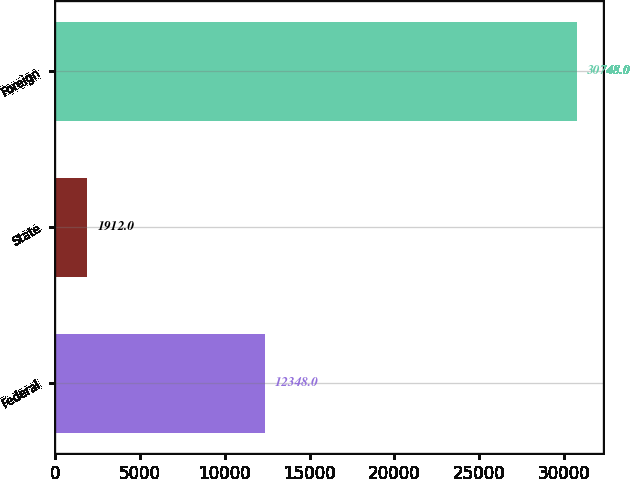Convert chart to OTSL. <chart><loc_0><loc_0><loc_500><loc_500><bar_chart><fcel>Federal<fcel>State<fcel>Foreign<nl><fcel>12348<fcel>1912<fcel>30748<nl></chart> 